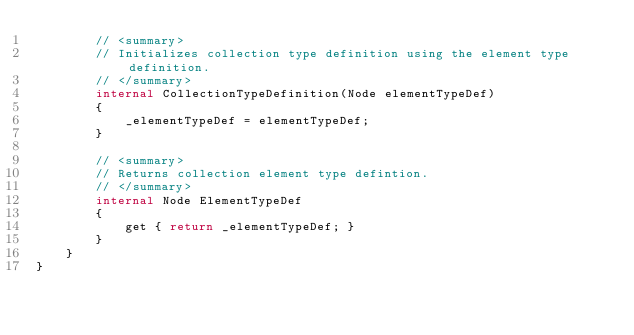<code> <loc_0><loc_0><loc_500><loc_500><_C#_>        // <summary>
        // Initializes collection type definition using the element type definition.
        // </summary>
        internal CollectionTypeDefinition(Node elementTypeDef)
        {
            _elementTypeDef = elementTypeDef;
        }

        // <summary>
        // Returns collection element type defintion.
        // </summary>
        internal Node ElementTypeDef
        {
            get { return _elementTypeDef; }
        }
    }
}
</code> 